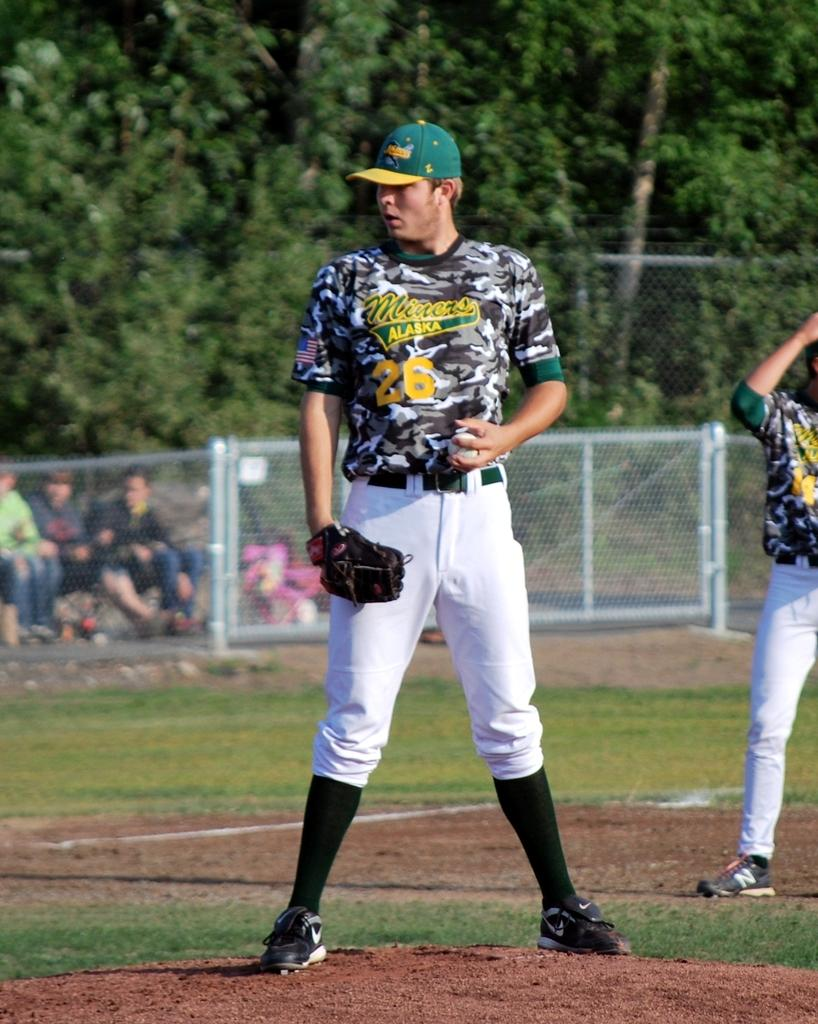<image>
Offer a succinct explanation of the picture presented. a baseball pitcher on the mound for the alaska miners 